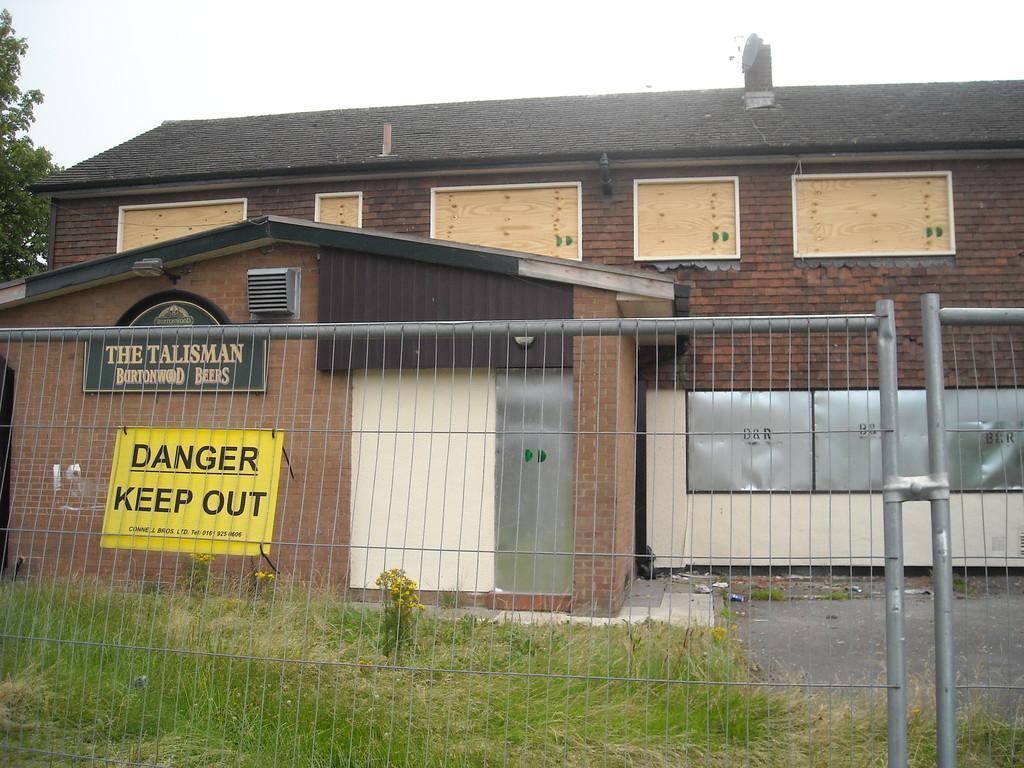In one or two sentences, can you explain what this image depicts? In this picture we can see a building here, there is a caution board here, at the bottom there is grass, we can see fencing here, on the left side there is a tree, we can see the sky at the top of the picture. 